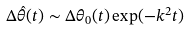<formula> <loc_0><loc_0><loc_500><loc_500>\Delta { \hat { \theta } } ( t ) \sim \Delta { \theta } _ { 0 } ( t ) \exp ( - k ^ { 2 } t )</formula> 